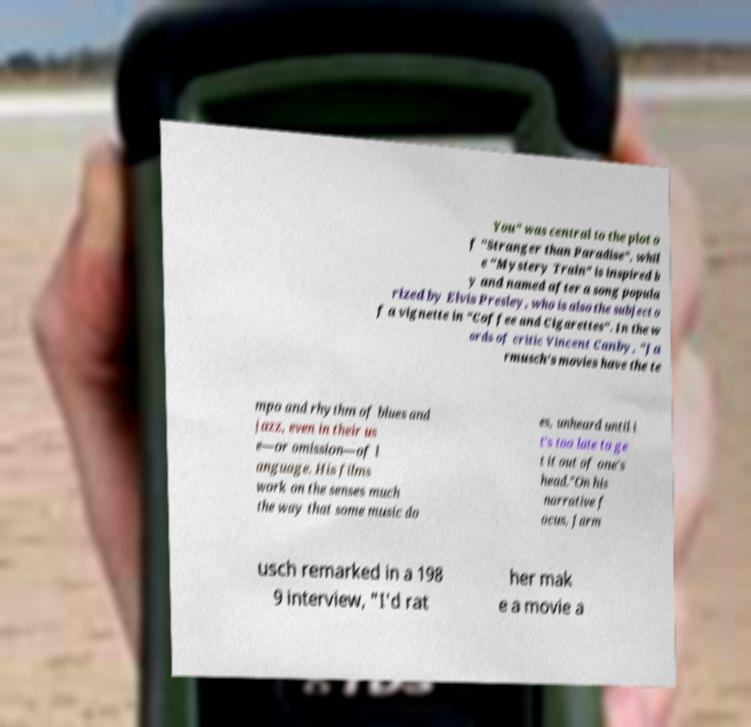Could you extract and type out the text from this image? You" was central to the plot o f "Stranger than Paradise", whil e "Mystery Train" is inspired b y and named after a song popula rized by Elvis Presley, who is also the subject o f a vignette in "Coffee and Cigarettes". In the w ords of critic Vincent Canby, "Ja rmusch's movies have the te mpo and rhythm of blues and jazz, even in their us e—or omission—of l anguage. His films work on the senses much the way that some music do es, unheard until i t's too late to ge t it out of one's head."On his narrative f ocus, Jarm usch remarked in a 198 9 interview, "I'd rat her mak e a movie a 